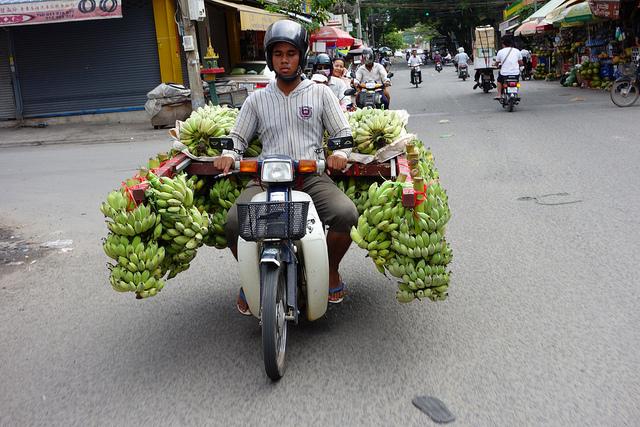What is he carrying on his scooter?
Short answer required. Bananas. Is he wearing a helmet?
Answer briefly. Yes. Is the man's shirt solid color?
Give a very brief answer. No. 